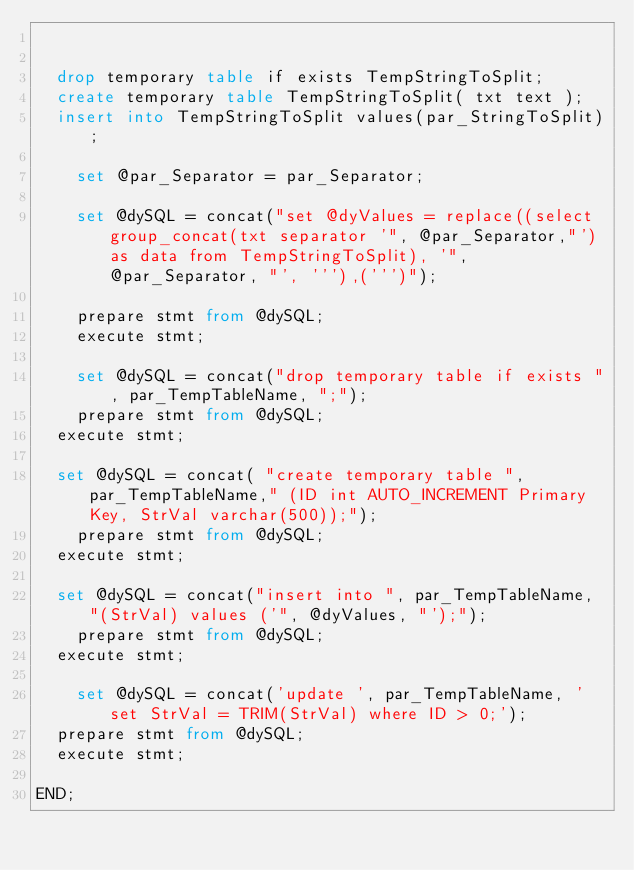<code> <loc_0><loc_0><loc_500><loc_500><_SQL_>	

	drop temporary table if exists TempStringToSplit;
	create temporary table TempStringToSplit( txt text );
	insert into TempStringToSplit values(par_StringToSplit);
    
    set @par_Separator = par_Separator;
    
    set @dySQL = concat("set @dyValues = replace((select group_concat(txt separator '", @par_Separator,"') as data from TempStringToSplit), '", @par_Separator, "', '''),(''')");
    
    prepare stmt from @dySQL;
    execute stmt;
    
    set @dySQL = concat("drop temporary table if exists ", par_TempTableName, ";");
    prepare stmt from @dySQL;
	execute stmt;
    
	set @dySQL = concat( "create temporary table ", par_TempTableName," (ID int AUTO_INCREMENT Primary Key, StrVal varchar(500));");
    prepare stmt from @dySQL;
	execute stmt;
    
	set @dySQL = concat("insert into ", par_TempTableName, "(StrVal) values ('", @dyValues, "');");
    prepare stmt from @dySQL;
	execute stmt;
    
    set @dySQL = concat('update ', par_TempTableName, ' set StrVal = TRIM(StrVal) where ID > 0;'); 
	prepare stmt from @dySQL;
	execute stmt;
    
END;

</code> 